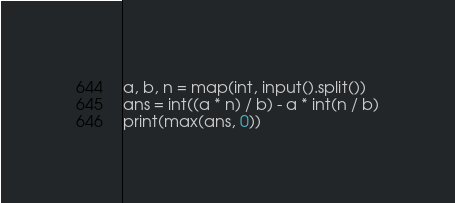Convert code to text. <code><loc_0><loc_0><loc_500><loc_500><_Python_>a, b, n = map(int, input().split())
ans = int((a * n) / b) - a * int(n / b)
print(max(ans, 0))</code> 